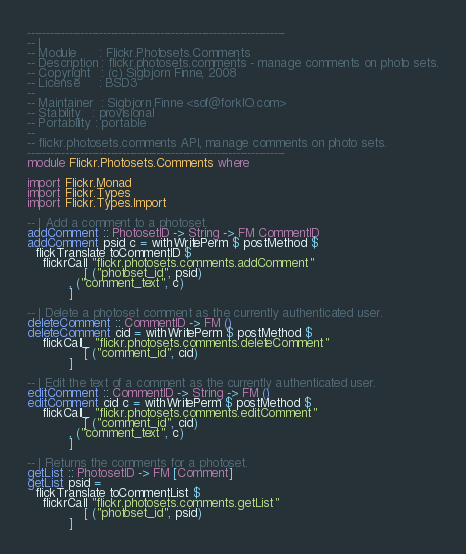<code> <loc_0><loc_0><loc_500><loc_500><_Haskell_>--------------------------------------------------------------------
-- |
-- Module      : Flickr.Photosets.Comments
-- Description : flickr.photosets.comments - manage comments on photo sets.
-- Copyright   : (c) Sigbjorn Finne, 2008
-- License     : BSD3
--
-- Maintainer  : Sigbjorn Finne <sof@forkIO.com>
-- Stability   : provisional
-- Portability : portable
--
-- flickr.photosets.comments API, manage comments on photo sets.
--------------------------------------------------------------------
module Flickr.Photosets.Comments where

import Flickr.Monad
import Flickr.Types
import Flickr.Types.Import

-- | Add a comment to a photoset.
addComment :: PhotosetID -> String -> FM CommentID
addComment psid c = withWritePerm $ postMethod $
  flickTranslate toCommentID $
    flickrCall "flickr.photosets.comments.addComment"
               [ ("photoset_id", psid)
           , ("comment_text", c)
           ]

-- | Delete a photoset comment as the currently authenticated user.
deleteComment :: CommentID -> FM ()
deleteComment cid = withWritePerm $ postMethod $
    flickCall_ "flickr.photosets.comments.deleteComment"
               [ ("comment_id", cid)
           ]

-- | Edit the text of a comment as the currently authenticated user.
editComment :: CommentID -> String -> FM ()
editComment cid c = withWritePerm $ postMethod $
    flickCall_ "flickr.photosets.comments.editComment"
               [ ("comment_id", cid)
           , ("comment_text", c)
           ]

-- | Returns the comments for a photoset.
getList :: PhotosetID -> FM [Comment]
getList psid =
  flickTranslate toCommentList $
    flickrCall "flickr.photosets.comments.getList"
               [ ("photoset_id", psid)
           ]


</code> 